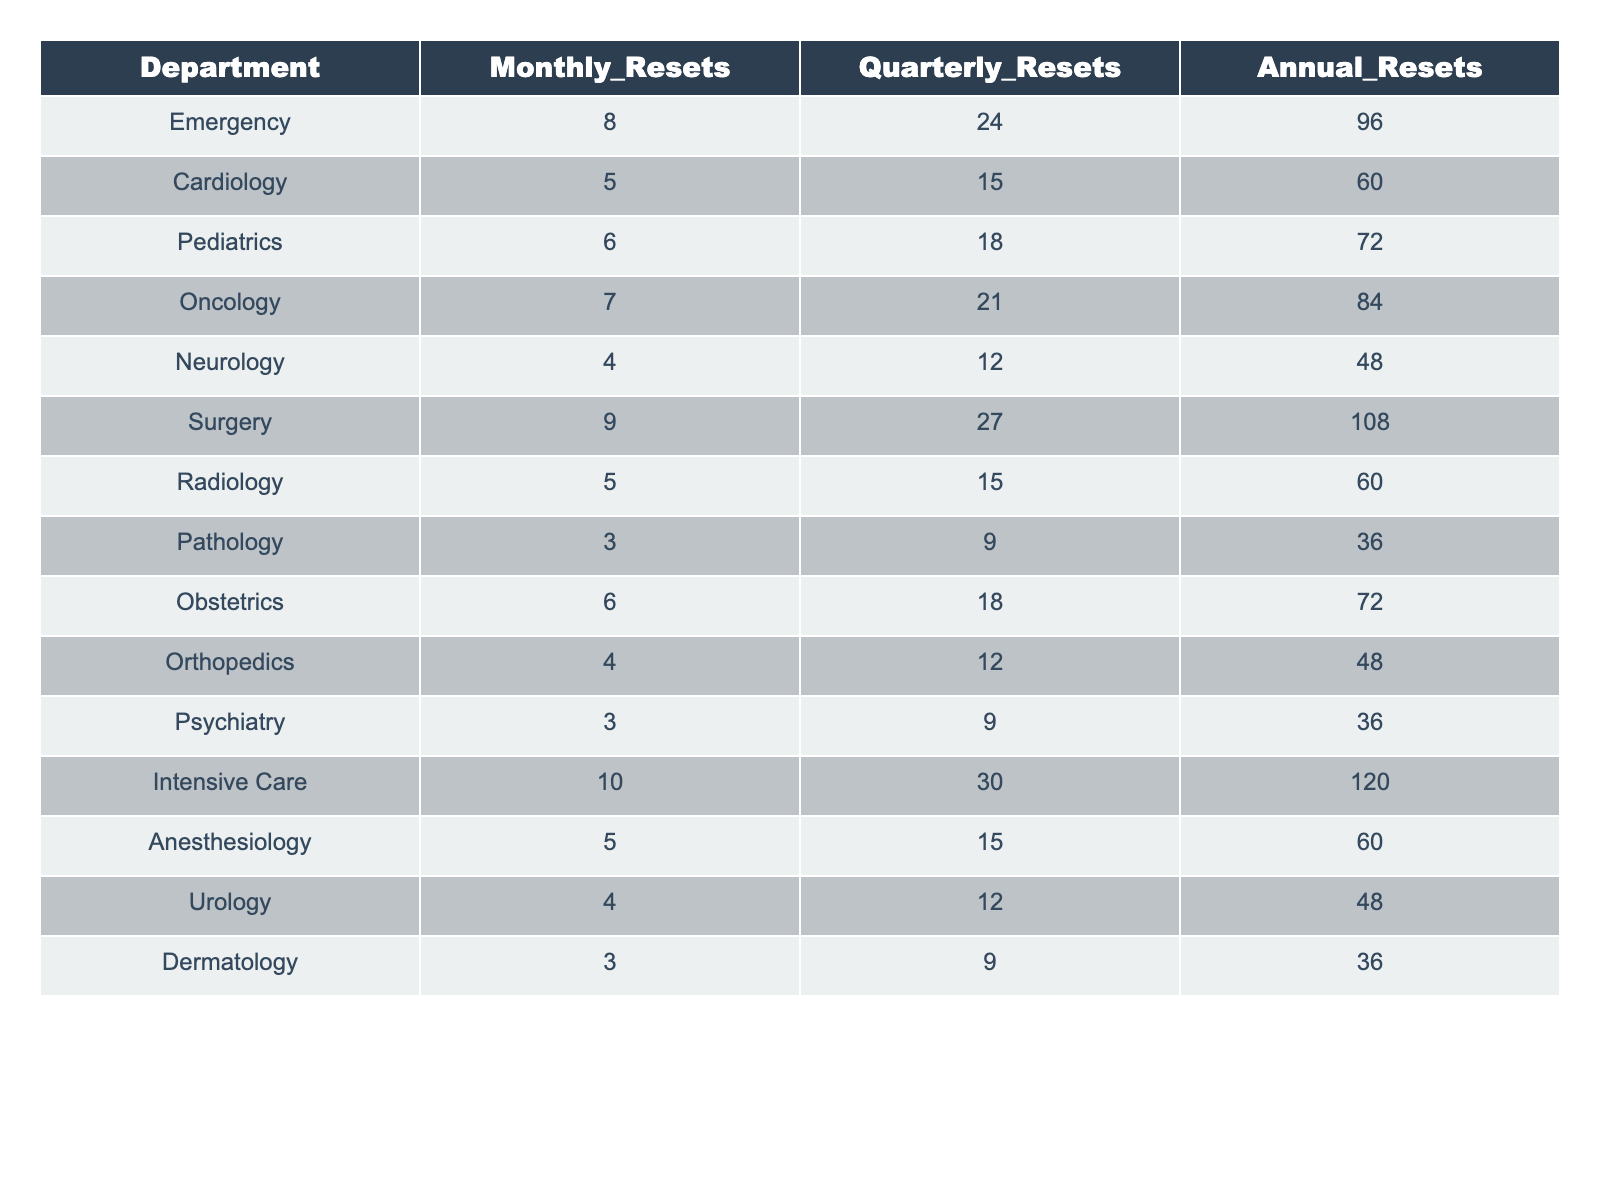What department has the highest monthly password resets? The table displays the monthly resets per department, and by examining the "Monthly_Resets" column, we see that Intensive Care has the highest value of 10.
Answer: Intensive Care How many total password resets does the Surgery department have in a year? To find the total annual resets for the Surgery department, we look at the "Annual_Resets" column and find the value listed as 108.
Answer: 108 Which department has the least number of quarterly resets? The "Quarterly_Resets" column is analyzed, with Pathology having the lowest value at 9.
Answer: Pathology What is the overall average monthly password resets across all departments? We sum the "Monthly_Resets" values: 8 + 5 + 6 + 7 + 4 + 9 + 5 + 3 + 6 + 4 + 3 + 10 + 5 + 4 + 3 =  5.3 and divide by 15 departments, yielding an average of 5.3.
Answer: 5.3 Is it true that at least one department has more than 25 quarterly resets? By reviewing the "Quarterly_Resets" column, we see the highest value is 30 (Intensive Care), confirming the statement is true.
Answer: True What is the total number of password resets for the Cardiology and Pediatrics departments combined? We add the "Monthly_Resets" for Cardiology (5) and Pediatrics (6), yielding a total of 11.
Answer: 11 Which department has a total of more than 60 annual resets? By reviewing the "Annual_Resets" column, we identify departments (e.g., Surgery, Intensive Care) with values above 60.
Answer: Surgery, Intensive Care What is the difference between the highest and lowest total annual resets? The highest annual resets is 120 (Intensive Care) and the lowest is 36 (Pathology), so the difference is 120 - 36 = 84.
Answer: 84 How many departments have a monthly reset value of 4 or less? Observing the "Monthly_Resets" column, three departments (Neurology, Orthopedics, Psychiatry) have values of 4 or less.
Answer: 3 What percentage of resets for the Emergency department are annual? The Emergency department has a total of 128 resets (8 monthly + 24 quarterly + 96 annual). The percentage for annual resets is (96/128) * 100 = 75%.
Answer: 75% 